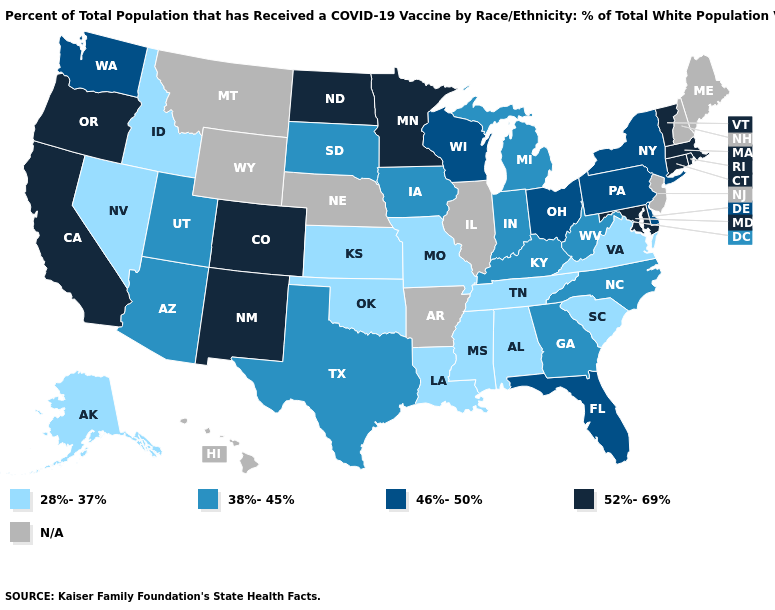Among the states that border Connecticut , does Massachusetts have the highest value?
Quick response, please. Yes. Name the states that have a value in the range 46%-50%?
Write a very short answer. Delaware, Florida, New York, Ohio, Pennsylvania, Washington, Wisconsin. Does the map have missing data?
Be succinct. Yes. Does the first symbol in the legend represent the smallest category?
Be succinct. Yes. Does Maryland have the highest value in the South?
Give a very brief answer. Yes. Which states have the lowest value in the Northeast?
Keep it brief. New York, Pennsylvania. What is the lowest value in states that border Illinois?
Write a very short answer. 28%-37%. Among the states that border Wyoming , which have the lowest value?
Be succinct. Idaho. What is the value of West Virginia?
Answer briefly. 38%-45%. Which states have the lowest value in the South?
Give a very brief answer. Alabama, Louisiana, Mississippi, Oklahoma, South Carolina, Tennessee, Virginia. Does Georgia have the lowest value in the USA?
Give a very brief answer. No. Does Alabama have the highest value in the USA?
Short answer required. No. Which states have the highest value in the USA?
Concise answer only. California, Colorado, Connecticut, Maryland, Massachusetts, Minnesota, New Mexico, North Dakota, Oregon, Rhode Island, Vermont. Does the map have missing data?
Write a very short answer. Yes. Which states have the lowest value in the USA?
Give a very brief answer. Alabama, Alaska, Idaho, Kansas, Louisiana, Mississippi, Missouri, Nevada, Oklahoma, South Carolina, Tennessee, Virginia. 